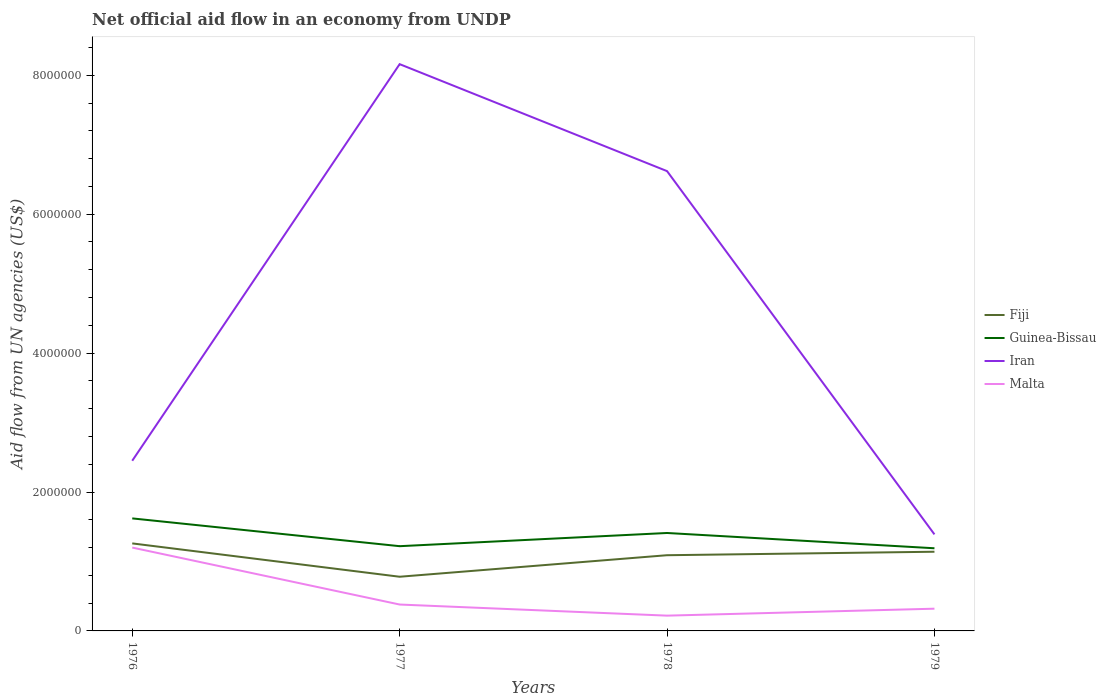Does the line corresponding to Guinea-Bissau intersect with the line corresponding to Iran?
Your answer should be very brief. No. Across all years, what is the maximum net official aid flow in Malta?
Provide a succinct answer. 2.20e+05. What is the total net official aid flow in Iran in the graph?
Offer a very short reply. -4.17e+06. What is the difference between the highest and the second highest net official aid flow in Iran?
Ensure brevity in your answer.  6.77e+06. What is the difference between the highest and the lowest net official aid flow in Guinea-Bissau?
Give a very brief answer. 2. How many lines are there?
Provide a succinct answer. 4. Are the values on the major ticks of Y-axis written in scientific E-notation?
Offer a terse response. No. How are the legend labels stacked?
Provide a succinct answer. Vertical. What is the title of the graph?
Your answer should be compact. Net official aid flow in an economy from UNDP. What is the label or title of the Y-axis?
Ensure brevity in your answer.  Aid flow from UN agencies (US$). What is the Aid flow from UN agencies (US$) in Fiji in 1976?
Your answer should be very brief. 1.26e+06. What is the Aid flow from UN agencies (US$) of Guinea-Bissau in 1976?
Provide a short and direct response. 1.62e+06. What is the Aid flow from UN agencies (US$) of Iran in 1976?
Offer a terse response. 2.45e+06. What is the Aid flow from UN agencies (US$) of Malta in 1976?
Your answer should be very brief. 1.20e+06. What is the Aid flow from UN agencies (US$) of Fiji in 1977?
Offer a terse response. 7.80e+05. What is the Aid flow from UN agencies (US$) in Guinea-Bissau in 1977?
Keep it short and to the point. 1.22e+06. What is the Aid flow from UN agencies (US$) in Iran in 1977?
Your answer should be very brief. 8.16e+06. What is the Aid flow from UN agencies (US$) of Fiji in 1978?
Give a very brief answer. 1.09e+06. What is the Aid flow from UN agencies (US$) in Guinea-Bissau in 1978?
Provide a succinct answer. 1.41e+06. What is the Aid flow from UN agencies (US$) of Iran in 1978?
Offer a terse response. 6.62e+06. What is the Aid flow from UN agencies (US$) in Malta in 1978?
Provide a succinct answer. 2.20e+05. What is the Aid flow from UN agencies (US$) in Fiji in 1979?
Offer a terse response. 1.14e+06. What is the Aid flow from UN agencies (US$) of Guinea-Bissau in 1979?
Ensure brevity in your answer.  1.19e+06. What is the Aid flow from UN agencies (US$) in Iran in 1979?
Give a very brief answer. 1.39e+06. Across all years, what is the maximum Aid flow from UN agencies (US$) of Fiji?
Provide a short and direct response. 1.26e+06. Across all years, what is the maximum Aid flow from UN agencies (US$) of Guinea-Bissau?
Provide a short and direct response. 1.62e+06. Across all years, what is the maximum Aid flow from UN agencies (US$) in Iran?
Your response must be concise. 8.16e+06. Across all years, what is the maximum Aid flow from UN agencies (US$) of Malta?
Give a very brief answer. 1.20e+06. Across all years, what is the minimum Aid flow from UN agencies (US$) of Fiji?
Ensure brevity in your answer.  7.80e+05. Across all years, what is the minimum Aid flow from UN agencies (US$) in Guinea-Bissau?
Make the answer very short. 1.19e+06. Across all years, what is the minimum Aid flow from UN agencies (US$) of Iran?
Keep it short and to the point. 1.39e+06. What is the total Aid flow from UN agencies (US$) of Fiji in the graph?
Your answer should be very brief. 4.27e+06. What is the total Aid flow from UN agencies (US$) in Guinea-Bissau in the graph?
Offer a very short reply. 5.44e+06. What is the total Aid flow from UN agencies (US$) of Iran in the graph?
Offer a very short reply. 1.86e+07. What is the total Aid flow from UN agencies (US$) in Malta in the graph?
Keep it short and to the point. 2.12e+06. What is the difference between the Aid flow from UN agencies (US$) of Guinea-Bissau in 1976 and that in 1977?
Your response must be concise. 4.00e+05. What is the difference between the Aid flow from UN agencies (US$) of Iran in 1976 and that in 1977?
Your answer should be very brief. -5.71e+06. What is the difference between the Aid flow from UN agencies (US$) in Malta in 1976 and that in 1977?
Keep it short and to the point. 8.20e+05. What is the difference between the Aid flow from UN agencies (US$) of Fiji in 1976 and that in 1978?
Provide a short and direct response. 1.70e+05. What is the difference between the Aid flow from UN agencies (US$) of Iran in 1976 and that in 1978?
Your answer should be compact. -4.17e+06. What is the difference between the Aid flow from UN agencies (US$) in Malta in 1976 and that in 1978?
Provide a succinct answer. 9.80e+05. What is the difference between the Aid flow from UN agencies (US$) in Fiji in 1976 and that in 1979?
Your answer should be compact. 1.20e+05. What is the difference between the Aid flow from UN agencies (US$) of Iran in 1976 and that in 1979?
Offer a very short reply. 1.06e+06. What is the difference between the Aid flow from UN agencies (US$) in Malta in 1976 and that in 1979?
Ensure brevity in your answer.  8.80e+05. What is the difference between the Aid flow from UN agencies (US$) of Fiji in 1977 and that in 1978?
Make the answer very short. -3.10e+05. What is the difference between the Aid flow from UN agencies (US$) of Guinea-Bissau in 1977 and that in 1978?
Provide a short and direct response. -1.90e+05. What is the difference between the Aid flow from UN agencies (US$) of Iran in 1977 and that in 1978?
Provide a short and direct response. 1.54e+06. What is the difference between the Aid flow from UN agencies (US$) in Malta in 1977 and that in 1978?
Provide a short and direct response. 1.60e+05. What is the difference between the Aid flow from UN agencies (US$) of Fiji in 1977 and that in 1979?
Ensure brevity in your answer.  -3.60e+05. What is the difference between the Aid flow from UN agencies (US$) of Iran in 1977 and that in 1979?
Provide a succinct answer. 6.77e+06. What is the difference between the Aid flow from UN agencies (US$) of Fiji in 1978 and that in 1979?
Keep it short and to the point. -5.00e+04. What is the difference between the Aid flow from UN agencies (US$) of Guinea-Bissau in 1978 and that in 1979?
Your response must be concise. 2.20e+05. What is the difference between the Aid flow from UN agencies (US$) in Iran in 1978 and that in 1979?
Your answer should be compact. 5.23e+06. What is the difference between the Aid flow from UN agencies (US$) in Fiji in 1976 and the Aid flow from UN agencies (US$) in Iran in 1977?
Provide a short and direct response. -6.90e+06. What is the difference between the Aid flow from UN agencies (US$) in Fiji in 1976 and the Aid flow from UN agencies (US$) in Malta in 1977?
Your answer should be very brief. 8.80e+05. What is the difference between the Aid flow from UN agencies (US$) in Guinea-Bissau in 1976 and the Aid flow from UN agencies (US$) in Iran in 1977?
Keep it short and to the point. -6.54e+06. What is the difference between the Aid flow from UN agencies (US$) in Guinea-Bissau in 1976 and the Aid flow from UN agencies (US$) in Malta in 1977?
Your answer should be very brief. 1.24e+06. What is the difference between the Aid flow from UN agencies (US$) of Iran in 1976 and the Aid flow from UN agencies (US$) of Malta in 1977?
Give a very brief answer. 2.07e+06. What is the difference between the Aid flow from UN agencies (US$) of Fiji in 1976 and the Aid flow from UN agencies (US$) of Guinea-Bissau in 1978?
Keep it short and to the point. -1.50e+05. What is the difference between the Aid flow from UN agencies (US$) in Fiji in 1976 and the Aid flow from UN agencies (US$) in Iran in 1978?
Make the answer very short. -5.36e+06. What is the difference between the Aid flow from UN agencies (US$) of Fiji in 1976 and the Aid flow from UN agencies (US$) of Malta in 1978?
Keep it short and to the point. 1.04e+06. What is the difference between the Aid flow from UN agencies (US$) in Guinea-Bissau in 1976 and the Aid flow from UN agencies (US$) in Iran in 1978?
Offer a very short reply. -5.00e+06. What is the difference between the Aid flow from UN agencies (US$) of Guinea-Bissau in 1976 and the Aid flow from UN agencies (US$) of Malta in 1978?
Offer a very short reply. 1.40e+06. What is the difference between the Aid flow from UN agencies (US$) of Iran in 1976 and the Aid flow from UN agencies (US$) of Malta in 1978?
Offer a very short reply. 2.23e+06. What is the difference between the Aid flow from UN agencies (US$) in Fiji in 1976 and the Aid flow from UN agencies (US$) in Iran in 1979?
Keep it short and to the point. -1.30e+05. What is the difference between the Aid flow from UN agencies (US$) in Fiji in 1976 and the Aid flow from UN agencies (US$) in Malta in 1979?
Ensure brevity in your answer.  9.40e+05. What is the difference between the Aid flow from UN agencies (US$) in Guinea-Bissau in 1976 and the Aid flow from UN agencies (US$) in Iran in 1979?
Provide a short and direct response. 2.30e+05. What is the difference between the Aid flow from UN agencies (US$) in Guinea-Bissau in 1976 and the Aid flow from UN agencies (US$) in Malta in 1979?
Your answer should be compact. 1.30e+06. What is the difference between the Aid flow from UN agencies (US$) in Iran in 1976 and the Aid flow from UN agencies (US$) in Malta in 1979?
Make the answer very short. 2.13e+06. What is the difference between the Aid flow from UN agencies (US$) of Fiji in 1977 and the Aid flow from UN agencies (US$) of Guinea-Bissau in 1978?
Give a very brief answer. -6.30e+05. What is the difference between the Aid flow from UN agencies (US$) of Fiji in 1977 and the Aid flow from UN agencies (US$) of Iran in 1978?
Your answer should be very brief. -5.84e+06. What is the difference between the Aid flow from UN agencies (US$) of Fiji in 1977 and the Aid flow from UN agencies (US$) of Malta in 1978?
Your answer should be very brief. 5.60e+05. What is the difference between the Aid flow from UN agencies (US$) of Guinea-Bissau in 1977 and the Aid flow from UN agencies (US$) of Iran in 1978?
Make the answer very short. -5.40e+06. What is the difference between the Aid flow from UN agencies (US$) of Iran in 1977 and the Aid flow from UN agencies (US$) of Malta in 1978?
Your answer should be compact. 7.94e+06. What is the difference between the Aid flow from UN agencies (US$) in Fiji in 1977 and the Aid flow from UN agencies (US$) in Guinea-Bissau in 1979?
Provide a succinct answer. -4.10e+05. What is the difference between the Aid flow from UN agencies (US$) of Fiji in 1977 and the Aid flow from UN agencies (US$) of Iran in 1979?
Ensure brevity in your answer.  -6.10e+05. What is the difference between the Aid flow from UN agencies (US$) in Iran in 1977 and the Aid flow from UN agencies (US$) in Malta in 1979?
Your answer should be compact. 7.84e+06. What is the difference between the Aid flow from UN agencies (US$) in Fiji in 1978 and the Aid flow from UN agencies (US$) in Guinea-Bissau in 1979?
Provide a succinct answer. -1.00e+05. What is the difference between the Aid flow from UN agencies (US$) in Fiji in 1978 and the Aid flow from UN agencies (US$) in Iran in 1979?
Make the answer very short. -3.00e+05. What is the difference between the Aid flow from UN agencies (US$) in Fiji in 1978 and the Aid flow from UN agencies (US$) in Malta in 1979?
Offer a very short reply. 7.70e+05. What is the difference between the Aid flow from UN agencies (US$) in Guinea-Bissau in 1978 and the Aid flow from UN agencies (US$) in Malta in 1979?
Your answer should be compact. 1.09e+06. What is the difference between the Aid flow from UN agencies (US$) of Iran in 1978 and the Aid flow from UN agencies (US$) of Malta in 1979?
Provide a short and direct response. 6.30e+06. What is the average Aid flow from UN agencies (US$) of Fiji per year?
Your answer should be very brief. 1.07e+06. What is the average Aid flow from UN agencies (US$) in Guinea-Bissau per year?
Provide a succinct answer. 1.36e+06. What is the average Aid flow from UN agencies (US$) in Iran per year?
Give a very brief answer. 4.66e+06. What is the average Aid flow from UN agencies (US$) of Malta per year?
Your answer should be very brief. 5.30e+05. In the year 1976, what is the difference between the Aid flow from UN agencies (US$) of Fiji and Aid flow from UN agencies (US$) of Guinea-Bissau?
Make the answer very short. -3.60e+05. In the year 1976, what is the difference between the Aid flow from UN agencies (US$) in Fiji and Aid flow from UN agencies (US$) in Iran?
Make the answer very short. -1.19e+06. In the year 1976, what is the difference between the Aid flow from UN agencies (US$) of Fiji and Aid flow from UN agencies (US$) of Malta?
Provide a short and direct response. 6.00e+04. In the year 1976, what is the difference between the Aid flow from UN agencies (US$) of Guinea-Bissau and Aid flow from UN agencies (US$) of Iran?
Ensure brevity in your answer.  -8.30e+05. In the year 1976, what is the difference between the Aid flow from UN agencies (US$) of Guinea-Bissau and Aid flow from UN agencies (US$) of Malta?
Your answer should be compact. 4.20e+05. In the year 1976, what is the difference between the Aid flow from UN agencies (US$) in Iran and Aid flow from UN agencies (US$) in Malta?
Keep it short and to the point. 1.25e+06. In the year 1977, what is the difference between the Aid flow from UN agencies (US$) in Fiji and Aid flow from UN agencies (US$) in Guinea-Bissau?
Offer a terse response. -4.40e+05. In the year 1977, what is the difference between the Aid flow from UN agencies (US$) in Fiji and Aid flow from UN agencies (US$) in Iran?
Offer a very short reply. -7.38e+06. In the year 1977, what is the difference between the Aid flow from UN agencies (US$) of Fiji and Aid flow from UN agencies (US$) of Malta?
Keep it short and to the point. 4.00e+05. In the year 1977, what is the difference between the Aid flow from UN agencies (US$) in Guinea-Bissau and Aid flow from UN agencies (US$) in Iran?
Keep it short and to the point. -6.94e+06. In the year 1977, what is the difference between the Aid flow from UN agencies (US$) in Guinea-Bissau and Aid flow from UN agencies (US$) in Malta?
Your answer should be compact. 8.40e+05. In the year 1977, what is the difference between the Aid flow from UN agencies (US$) of Iran and Aid flow from UN agencies (US$) of Malta?
Ensure brevity in your answer.  7.78e+06. In the year 1978, what is the difference between the Aid flow from UN agencies (US$) in Fiji and Aid flow from UN agencies (US$) in Guinea-Bissau?
Provide a short and direct response. -3.20e+05. In the year 1978, what is the difference between the Aid flow from UN agencies (US$) of Fiji and Aid flow from UN agencies (US$) of Iran?
Your answer should be compact. -5.53e+06. In the year 1978, what is the difference between the Aid flow from UN agencies (US$) in Fiji and Aid flow from UN agencies (US$) in Malta?
Make the answer very short. 8.70e+05. In the year 1978, what is the difference between the Aid flow from UN agencies (US$) in Guinea-Bissau and Aid flow from UN agencies (US$) in Iran?
Provide a succinct answer. -5.21e+06. In the year 1978, what is the difference between the Aid flow from UN agencies (US$) of Guinea-Bissau and Aid flow from UN agencies (US$) of Malta?
Your answer should be very brief. 1.19e+06. In the year 1978, what is the difference between the Aid flow from UN agencies (US$) of Iran and Aid flow from UN agencies (US$) of Malta?
Your answer should be compact. 6.40e+06. In the year 1979, what is the difference between the Aid flow from UN agencies (US$) of Fiji and Aid flow from UN agencies (US$) of Iran?
Your answer should be very brief. -2.50e+05. In the year 1979, what is the difference between the Aid flow from UN agencies (US$) in Fiji and Aid flow from UN agencies (US$) in Malta?
Ensure brevity in your answer.  8.20e+05. In the year 1979, what is the difference between the Aid flow from UN agencies (US$) of Guinea-Bissau and Aid flow from UN agencies (US$) of Malta?
Provide a short and direct response. 8.70e+05. In the year 1979, what is the difference between the Aid flow from UN agencies (US$) of Iran and Aid flow from UN agencies (US$) of Malta?
Keep it short and to the point. 1.07e+06. What is the ratio of the Aid flow from UN agencies (US$) in Fiji in 1976 to that in 1977?
Offer a terse response. 1.62. What is the ratio of the Aid flow from UN agencies (US$) of Guinea-Bissau in 1976 to that in 1977?
Your answer should be very brief. 1.33. What is the ratio of the Aid flow from UN agencies (US$) of Iran in 1976 to that in 1977?
Make the answer very short. 0.3. What is the ratio of the Aid flow from UN agencies (US$) of Malta in 1976 to that in 1977?
Your answer should be very brief. 3.16. What is the ratio of the Aid flow from UN agencies (US$) in Fiji in 1976 to that in 1978?
Ensure brevity in your answer.  1.16. What is the ratio of the Aid flow from UN agencies (US$) in Guinea-Bissau in 1976 to that in 1978?
Keep it short and to the point. 1.15. What is the ratio of the Aid flow from UN agencies (US$) in Iran in 1976 to that in 1978?
Offer a terse response. 0.37. What is the ratio of the Aid flow from UN agencies (US$) of Malta in 1976 to that in 1978?
Your answer should be compact. 5.45. What is the ratio of the Aid flow from UN agencies (US$) in Fiji in 1976 to that in 1979?
Your answer should be very brief. 1.11. What is the ratio of the Aid flow from UN agencies (US$) in Guinea-Bissau in 1976 to that in 1979?
Make the answer very short. 1.36. What is the ratio of the Aid flow from UN agencies (US$) in Iran in 1976 to that in 1979?
Your answer should be compact. 1.76. What is the ratio of the Aid flow from UN agencies (US$) of Malta in 1976 to that in 1979?
Provide a short and direct response. 3.75. What is the ratio of the Aid flow from UN agencies (US$) in Fiji in 1977 to that in 1978?
Make the answer very short. 0.72. What is the ratio of the Aid flow from UN agencies (US$) of Guinea-Bissau in 1977 to that in 1978?
Offer a terse response. 0.87. What is the ratio of the Aid flow from UN agencies (US$) of Iran in 1977 to that in 1978?
Make the answer very short. 1.23. What is the ratio of the Aid flow from UN agencies (US$) of Malta in 1977 to that in 1978?
Provide a succinct answer. 1.73. What is the ratio of the Aid flow from UN agencies (US$) of Fiji in 1977 to that in 1979?
Ensure brevity in your answer.  0.68. What is the ratio of the Aid flow from UN agencies (US$) of Guinea-Bissau in 1977 to that in 1979?
Provide a succinct answer. 1.03. What is the ratio of the Aid flow from UN agencies (US$) in Iran in 1977 to that in 1979?
Give a very brief answer. 5.87. What is the ratio of the Aid flow from UN agencies (US$) in Malta in 1977 to that in 1979?
Provide a succinct answer. 1.19. What is the ratio of the Aid flow from UN agencies (US$) of Fiji in 1978 to that in 1979?
Your answer should be compact. 0.96. What is the ratio of the Aid flow from UN agencies (US$) of Guinea-Bissau in 1978 to that in 1979?
Provide a short and direct response. 1.18. What is the ratio of the Aid flow from UN agencies (US$) of Iran in 1978 to that in 1979?
Offer a terse response. 4.76. What is the ratio of the Aid flow from UN agencies (US$) in Malta in 1978 to that in 1979?
Offer a very short reply. 0.69. What is the difference between the highest and the second highest Aid flow from UN agencies (US$) in Fiji?
Offer a very short reply. 1.20e+05. What is the difference between the highest and the second highest Aid flow from UN agencies (US$) of Guinea-Bissau?
Give a very brief answer. 2.10e+05. What is the difference between the highest and the second highest Aid flow from UN agencies (US$) in Iran?
Your response must be concise. 1.54e+06. What is the difference between the highest and the second highest Aid flow from UN agencies (US$) of Malta?
Provide a short and direct response. 8.20e+05. What is the difference between the highest and the lowest Aid flow from UN agencies (US$) of Iran?
Offer a very short reply. 6.77e+06. What is the difference between the highest and the lowest Aid flow from UN agencies (US$) of Malta?
Your answer should be very brief. 9.80e+05. 